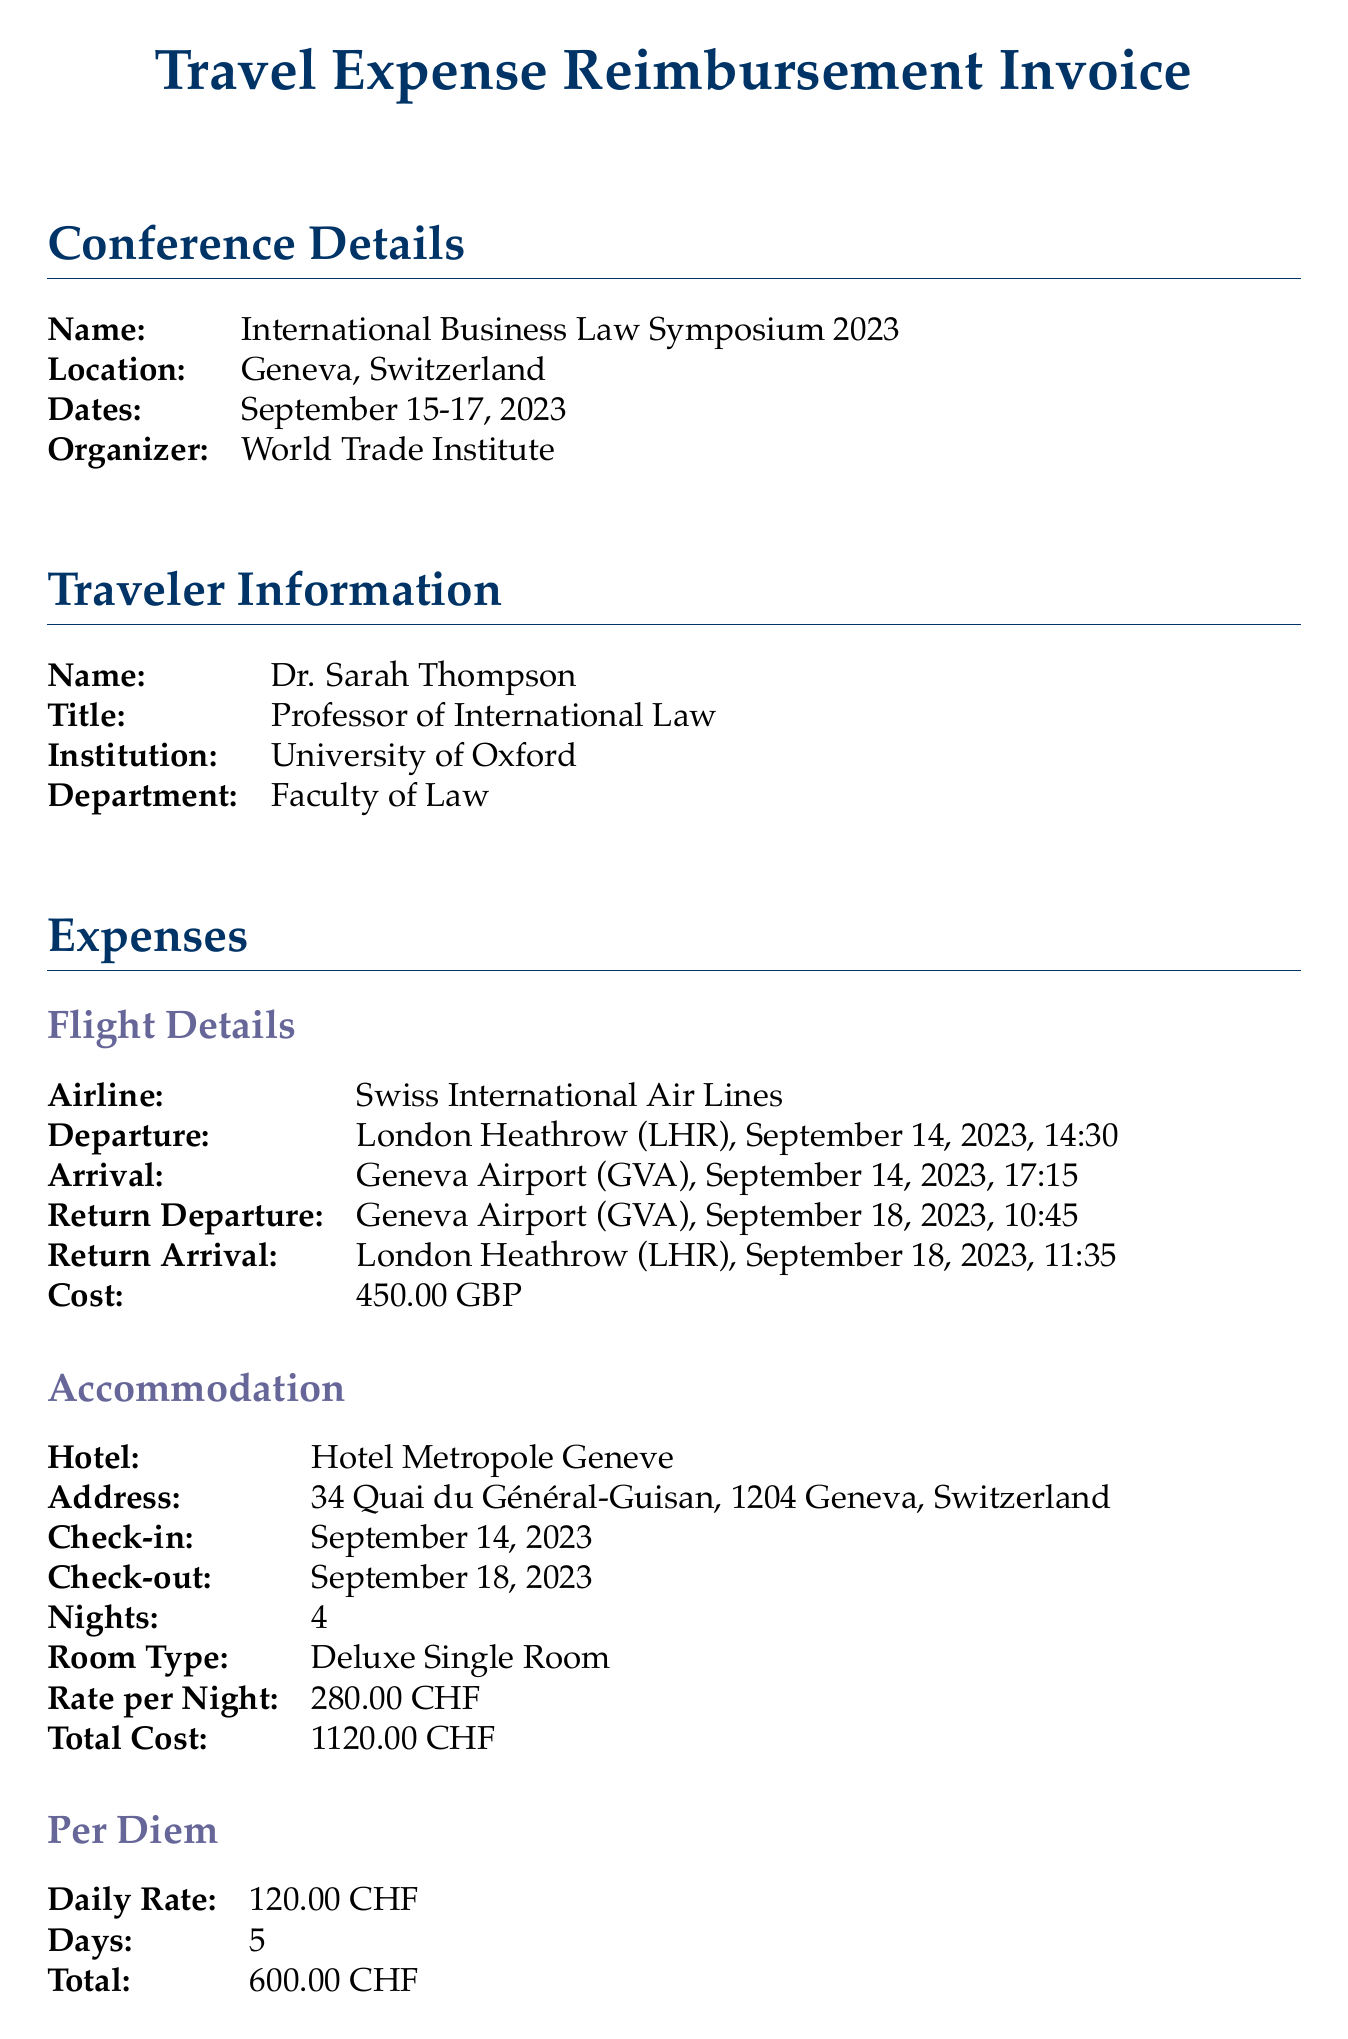what is the name of the conference? The name of the conference is mentioned in the document under Conference Details.
Answer: International Business Law Symposium 2023 who is the traveler? The traveler's name is provided in the Traveler Information section of the document.
Answer: Dr. Sarah Thompson how much was the flight cost in GBP? The flight cost is specified under Flight Details in GBP.
Answer: 450.00 GBP what is the total cost for accommodation in CHF? The total cost for accommodation is listed in the Accommodation section.
Answer: 1120.00 CHF what is the daily rate for per diem? The daily rate for per diem is provided in the Per Diem section.
Answer: 120.00 CHF how many nights did the traveler stay at the hotel? The number of nights stayed is stated in the Accommodation section.
Answer: 4 what additional expense was incurred for the airport transfer from the hotel? The additional expenses include specific descriptions and amounts, including one for the hotel to airport transfer.
Answer: 50.00 CHF what is the total number of days accounted for per diem? The total number of days is outlined in the Per Diem section of the document.
Answer: 5 what is the grant name associated with the funding source? The grant name is mentioned in the Funding Source section.
Answer: European Research Council (ERC) Advanced Grant 